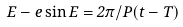Convert formula to latex. <formula><loc_0><loc_0><loc_500><loc_500>E - e \sin E = 2 \pi / P ( t - T )</formula> 